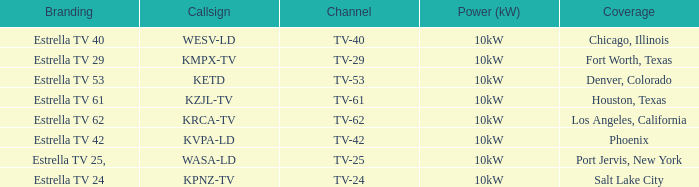Which area did estrella tv 62 provide coverage for? Los Angeles, California. 